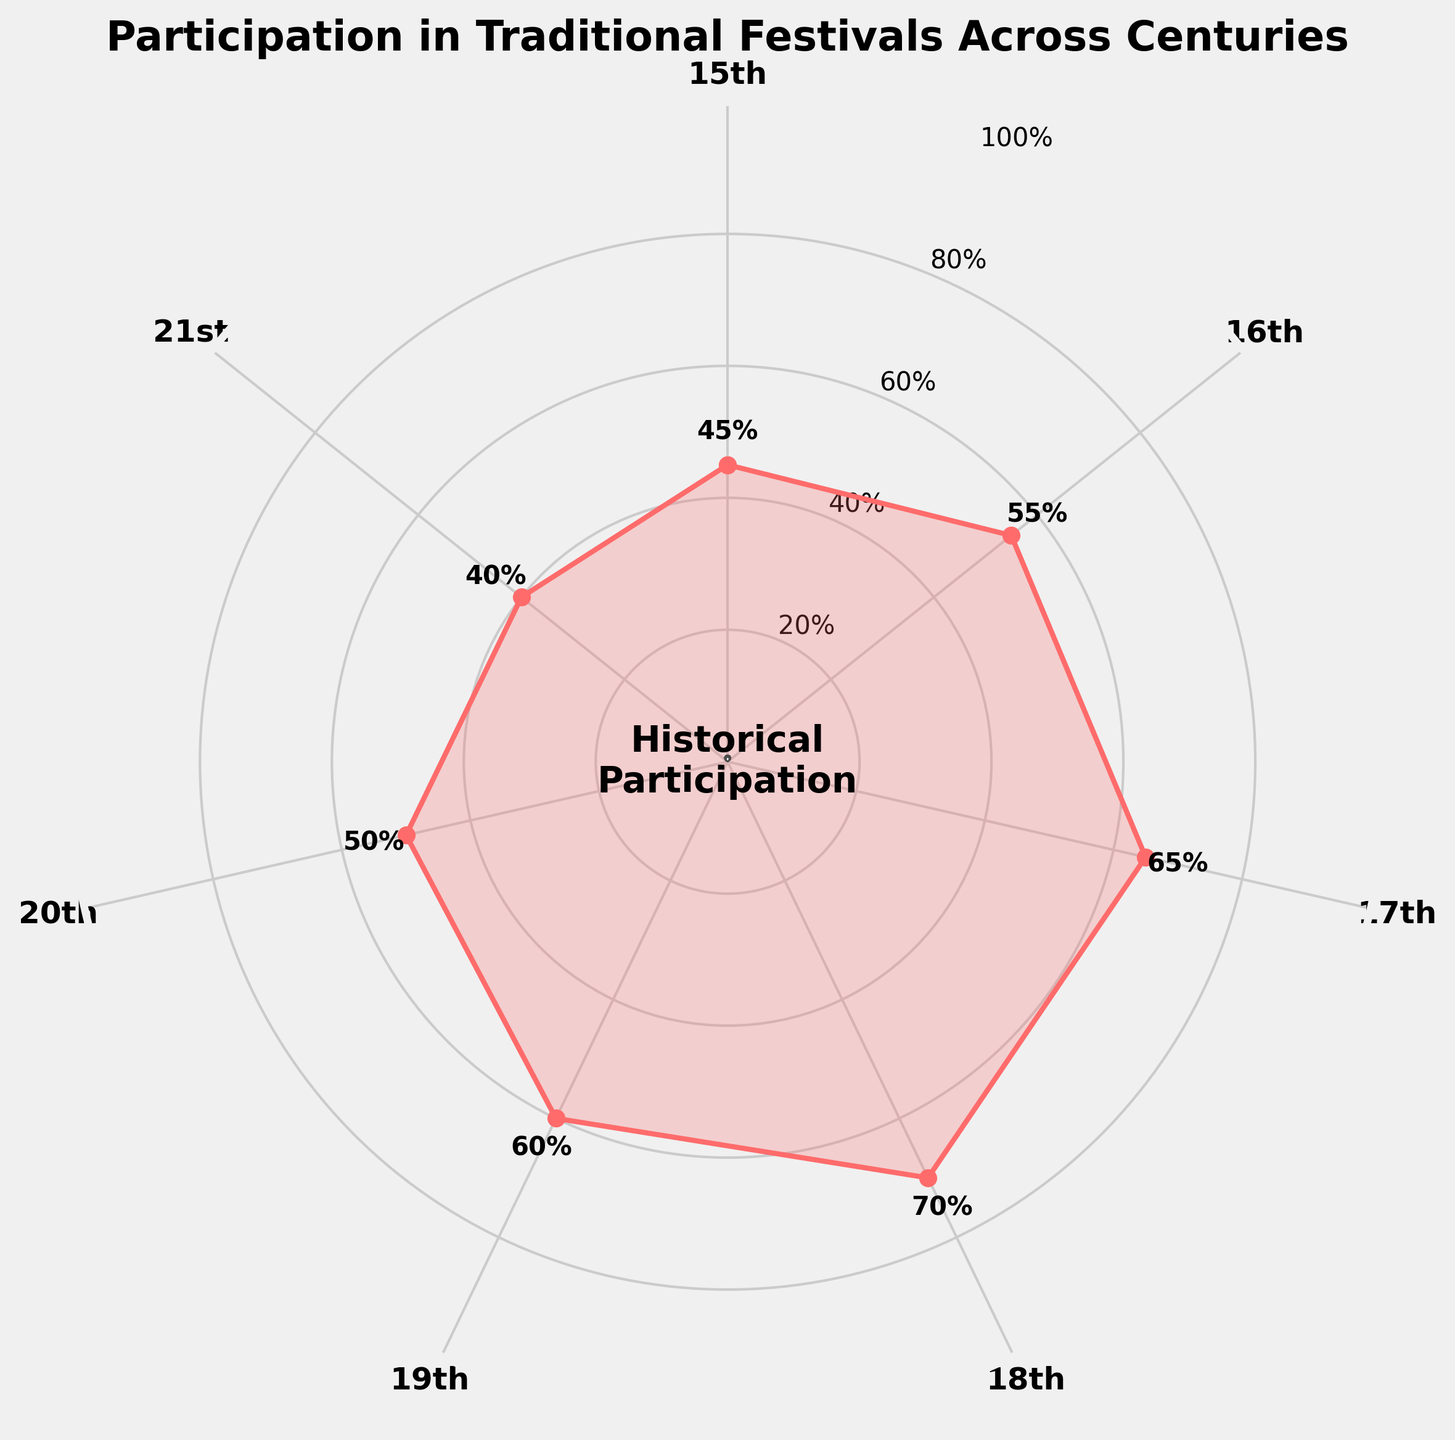What's the title of the figure? The title is written at the top of the figure as "Participation in Traditional Festivals Across Centuries."
Answer: "Participation in Traditional Festivals Across Centuries" How many centuries are represented on the figure? Each century is represented along the circular perimeter. Counting each label provides the total number of centuries.
Answer: 7 Which century had the highest percentage of participation in traditional festivals? The highest point on the radial plot shows the century with the peak participation percentage.
Answer: 18th What is the participation percentage for the 21st century? Find the label for the 21st century and look at the numerical value associated with it.
Answer: 40% What's the average participation percentage across these centuries? Add the percentages and divide by the number of centuries. The calculation is (45 + 55 + 65 + 70 + 60 + 50 + 40) / 7.
Answer: 55% How does the participation in the 19th century compare with the 20th century? Look at the participation percentages for both centuries and compare them. The 19th century has 60%, and the 20th century has 50%.
Answer: The 19th century had a higher participation percentage Which century saw a drop in participation compared to the previous one, and by how much? Identify the pairs of consecutive centuries and their participation percentages. Calculate the differences where the latter value is smaller than the former. Between the 18th and 19th centuries, it dropped from 70% to 60%.
Answer: The 19th century saw a drop of 10% Is there any century where the participation percentage stayed the same as another century? Compare each century's percentage to see if any two are equal.
Answer: No What trends can be observed in the participation percentages over the centuries? Look for patterns in the data. The percentage increases from the 15th to the 18th century, decreases in the 19th, 20th, and 21st centuries.
Answer: Increasing trend until the 18th century, then decreases Why is the center circle labeled "Historical Participation"? The center circle serves as a focal point for the gauge chart and summarizes the overall theme of the data visualized.
Answer: Summarizes the theme of the data visualized 